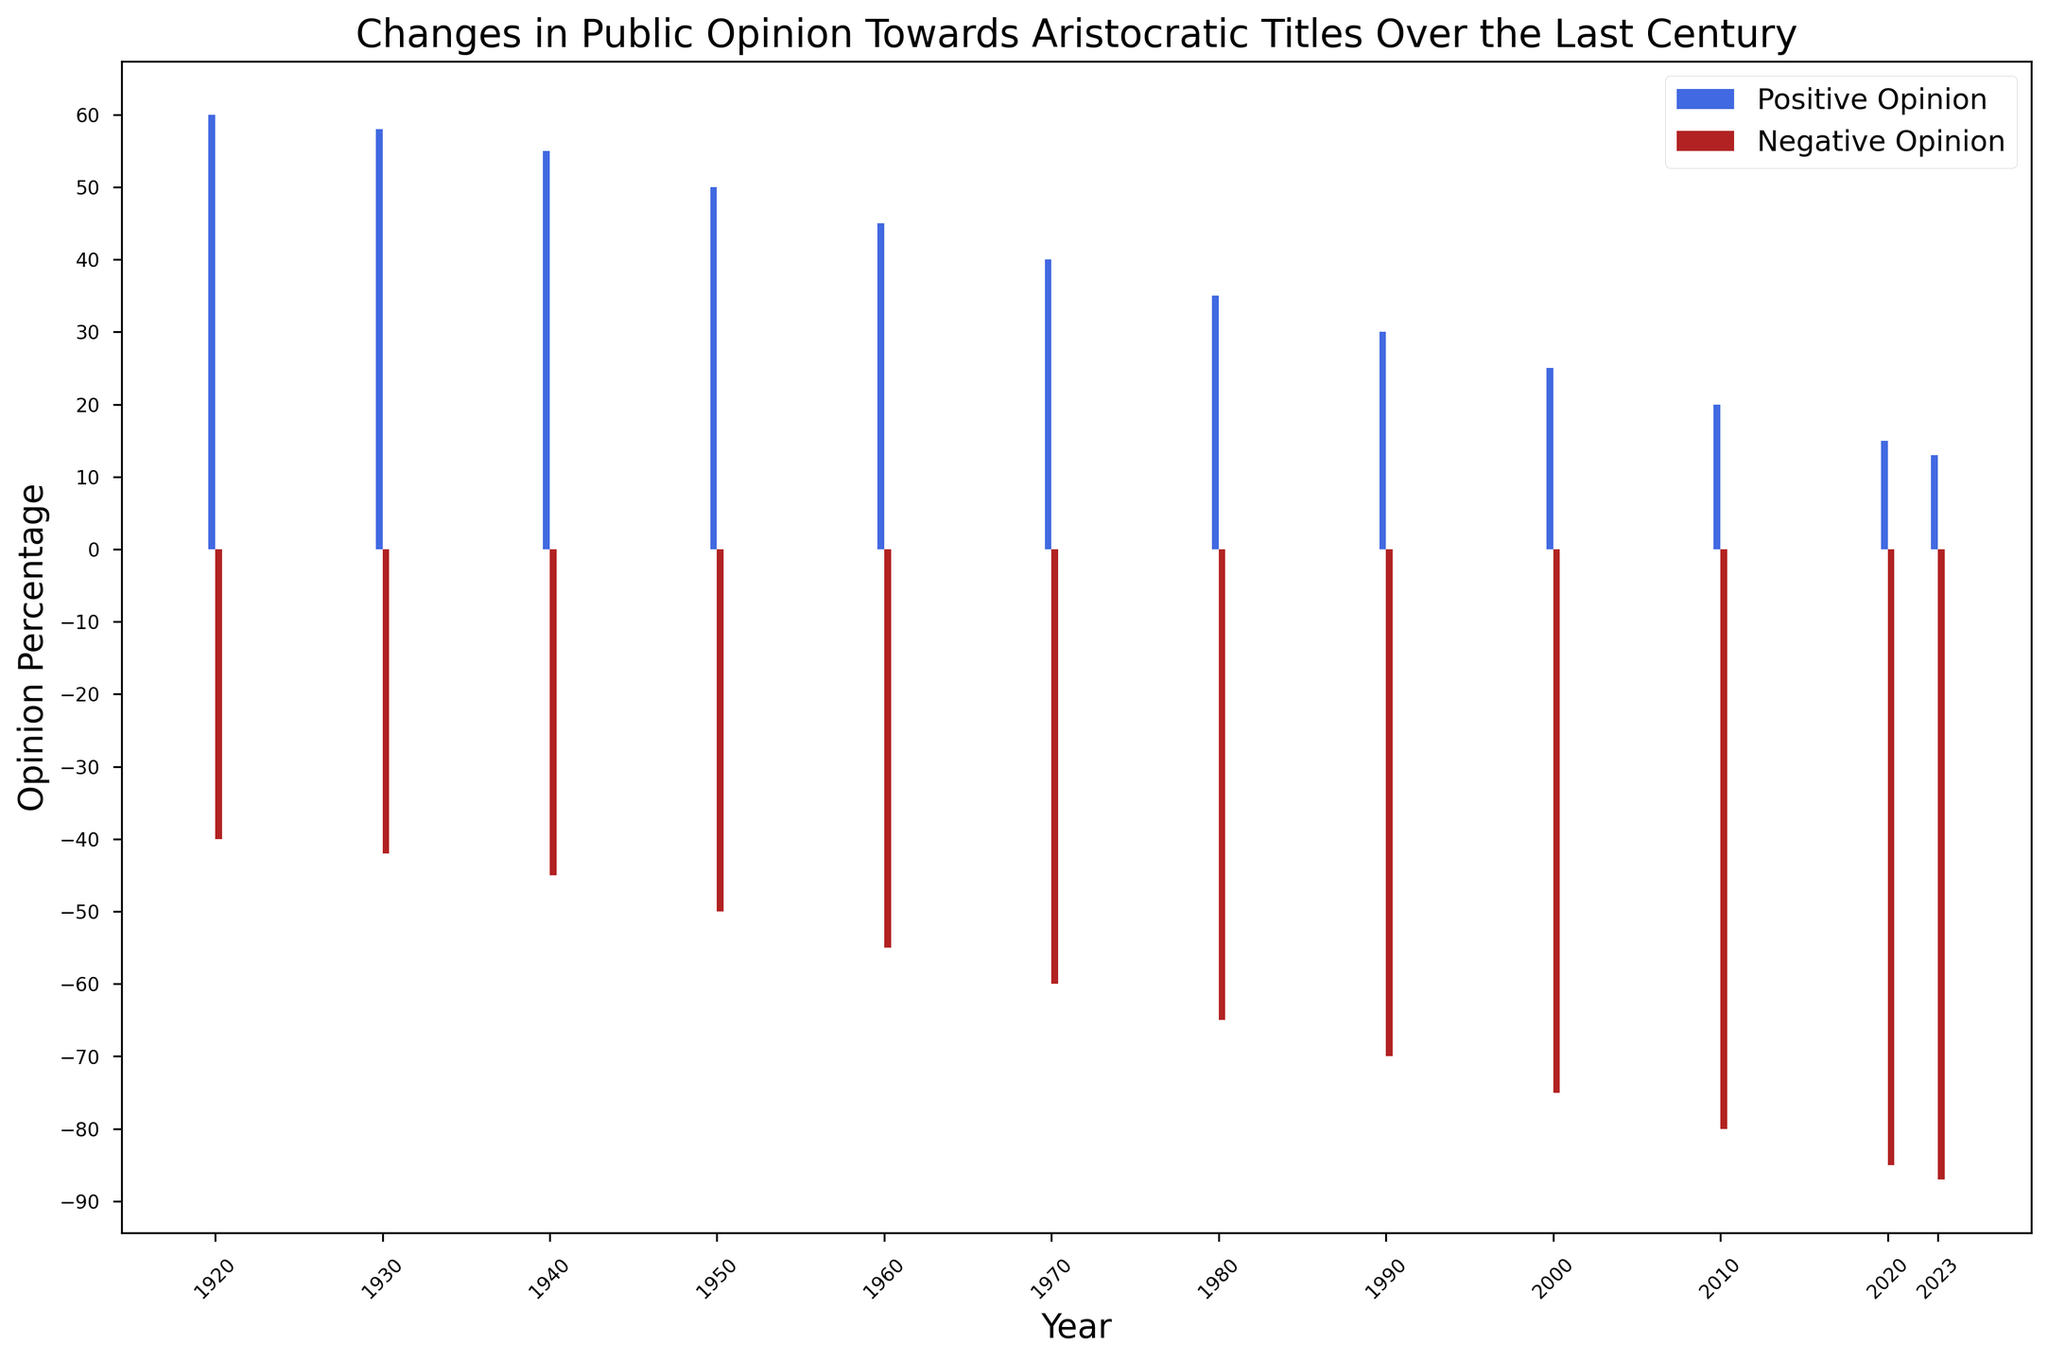What is the trend in public opinion towards aristocratic titles over the last century? By observing the bars for both positive and negative opinions from 1920 to 2023, one can see that the positive opinion bars decrease in height while the negative opinion bars increase. This indicates a declining trend in positive opinions and a rising trend in negative opinions.
Answer: Negative trend in positive opinions, positive trend in negative opinions Which year had the highest positive opinion percentage and what was it? The bar for the year 1920 is the tallest among the positive opinion bars, reaching up to 60%.
Answer: 1920, 60% What is the difference between positive and negative opinions in the year 1950? In the figure, the positive opinion for 1950 is 50% and the negative opinion is -50%. The difference is calculated by taking the magnitude difference of these values: 50 - (-50) = 100.
Answer: 100% How do the positive and negative opinions compare in 2023? For the year 2023, the positive opinion bar is 13% and the negative opinion bar is -87%. The negative opinion is much higher than the positive opinion by observing the length of the bars.
Answer: Negative opinion is much higher In which decades did the negative opinion exceed 60%? By checking the negative opinion bars, we see that from 1980 onwards, the negative opinion bars are longer than 60%.
Answer: 1980, 1990, 2000, 2010, 2020, 2023 What is the average positive opinion across all the years displayed? To find the average positive opinion, add the positive opinion percentages and divide by the number of years: (60 + 58 + 55 + 50 + 45 + 40 + 35 + 30 + 25 + 20 + 15 + 13) / 12 = 38.25.
Answer: 38.25% How did public opinion change from 2000 to 2020? From 2000 to 2020, the positive opinion dropped from 25% to 15% while the negative opinion increased from -75% to -85%. This indicates a further decline in positive views and an increase in negative ones.
Answer: Declined in positive, increased in negative What is the median negative opinion value shown in the figure? To find the median, arrange the negative opinions in order: -87, -85, -80, -75, -70, -65, -60, -55, -50, -45, -42, -40. The median is the average of the 6th and 7th values: (-65 - 60) / 2 = -62.5.
Answer: -62.5% Between which decades did the positive opinion decline the most? The positive opinion dropped significantly between 1970 (40%) and 1980 (35%), a drop of 5%. This requires comparing each decade's drop.
Answer: 1970 to 1980 What color represents the negative opinion bars in the figure? The negative opinion bars are colored in a red hue, specifically noted as "firebrick" in the styling.
Answer: Red 